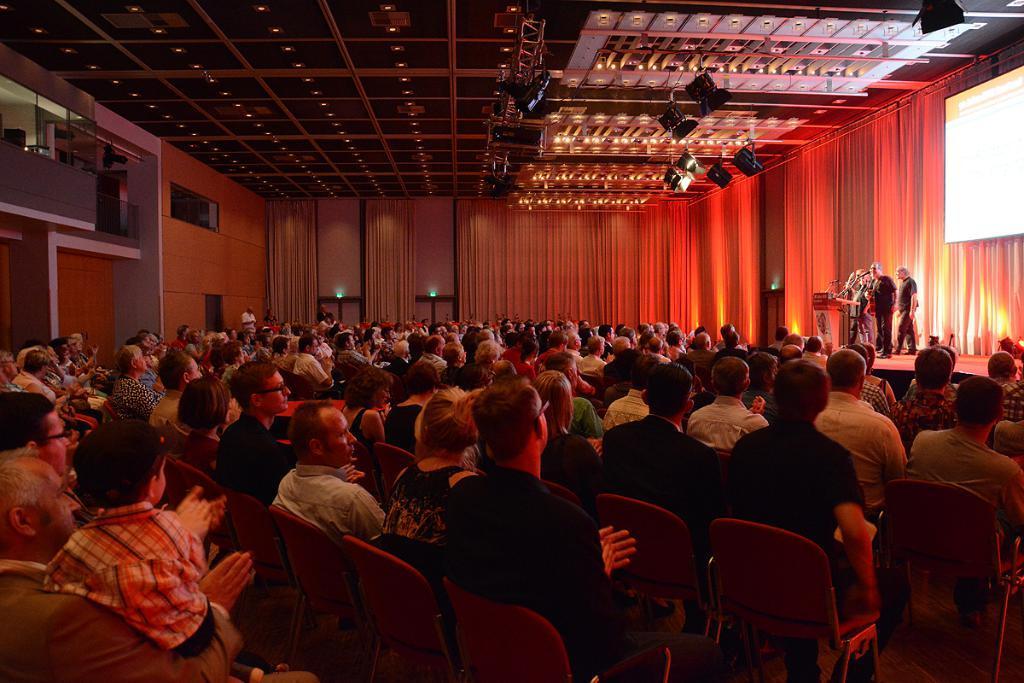Can you describe this image briefly? This picture shows a group of people seated on the chairs and we see people standing on the dais and speaking at a podium and we see a projector screen on the wall 